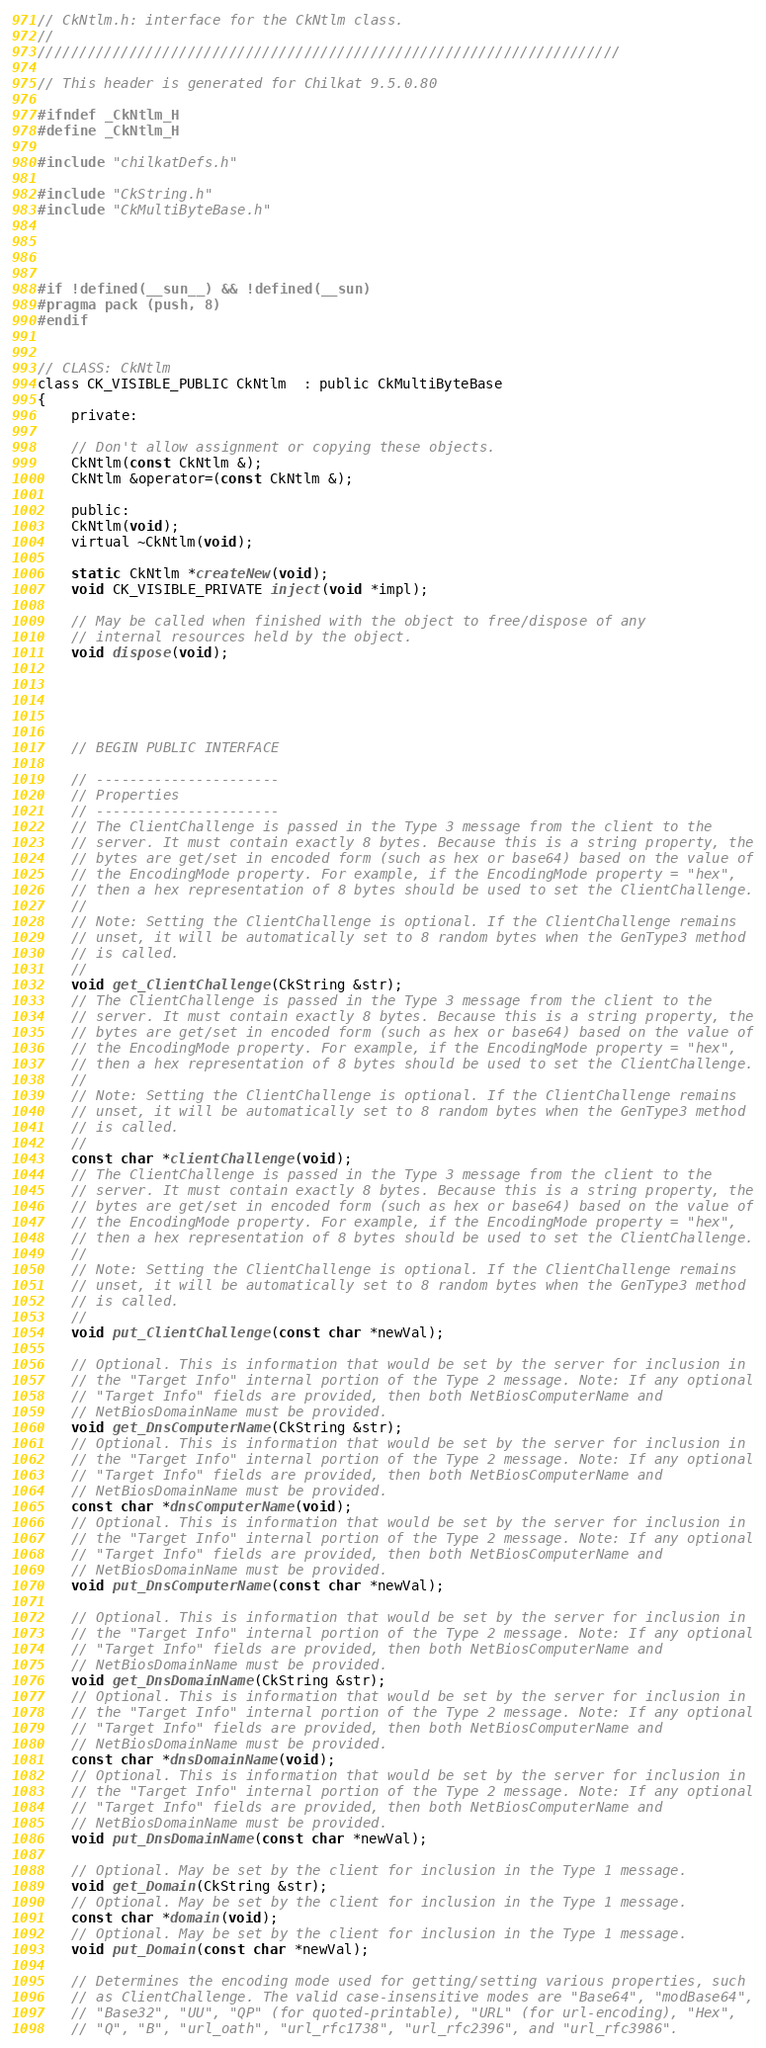Convert code to text. <code><loc_0><loc_0><loc_500><loc_500><_C_>// CkNtlm.h: interface for the CkNtlm class.
//
//////////////////////////////////////////////////////////////////////

// This header is generated for Chilkat 9.5.0.80

#ifndef _CkNtlm_H
#define _CkNtlm_H
	
#include "chilkatDefs.h"

#include "CkString.h"
#include "CkMultiByteBase.h"




#if !defined(__sun__) && !defined(__sun)
#pragma pack (push, 8)
#endif
 

// CLASS: CkNtlm
class CK_VISIBLE_PUBLIC CkNtlm  : public CkMultiByteBase
{
    private:

	// Don't allow assignment or copying these objects.
	CkNtlm(const CkNtlm &);
	CkNtlm &operator=(const CkNtlm &);

    public:
	CkNtlm(void);
	virtual ~CkNtlm(void);

	static CkNtlm *createNew(void);
	void CK_VISIBLE_PRIVATE inject(void *impl);

	// May be called when finished with the object to free/dispose of any
	// internal resources held by the object. 
	void dispose(void);

	
		
	

	// BEGIN PUBLIC INTERFACE

	// ----------------------
	// Properties
	// ----------------------
	// The ClientChallenge is passed in the Type 3 message from the client to the
	// server. It must contain exactly 8 bytes. Because this is a string property, the
	// bytes are get/set in encoded form (such as hex or base64) based on the value of
	// the EncodingMode property. For example, if the EncodingMode property = "hex",
	// then a hex representation of 8 bytes should be used to set the ClientChallenge.
	// 
	// Note: Setting the ClientChallenge is optional. If the ClientChallenge remains
	// unset, it will be automatically set to 8 random bytes when the GenType3 method
	// is called.
	// 
	void get_ClientChallenge(CkString &str);
	// The ClientChallenge is passed in the Type 3 message from the client to the
	// server. It must contain exactly 8 bytes. Because this is a string property, the
	// bytes are get/set in encoded form (such as hex or base64) based on the value of
	// the EncodingMode property. For example, if the EncodingMode property = "hex",
	// then a hex representation of 8 bytes should be used to set the ClientChallenge.
	// 
	// Note: Setting the ClientChallenge is optional. If the ClientChallenge remains
	// unset, it will be automatically set to 8 random bytes when the GenType3 method
	// is called.
	// 
	const char *clientChallenge(void);
	// The ClientChallenge is passed in the Type 3 message from the client to the
	// server. It must contain exactly 8 bytes. Because this is a string property, the
	// bytes are get/set in encoded form (such as hex or base64) based on the value of
	// the EncodingMode property. For example, if the EncodingMode property = "hex",
	// then a hex representation of 8 bytes should be used to set the ClientChallenge.
	// 
	// Note: Setting the ClientChallenge is optional. If the ClientChallenge remains
	// unset, it will be automatically set to 8 random bytes when the GenType3 method
	// is called.
	// 
	void put_ClientChallenge(const char *newVal);

	// Optional. This is information that would be set by the server for inclusion in
	// the "Target Info" internal portion of the Type 2 message. Note: If any optional
	// "Target Info" fields are provided, then both NetBiosComputerName and
	// NetBiosDomainName must be provided.
	void get_DnsComputerName(CkString &str);
	// Optional. This is information that would be set by the server for inclusion in
	// the "Target Info" internal portion of the Type 2 message. Note: If any optional
	// "Target Info" fields are provided, then both NetBiosComputerName and
	// NetBiosDomainName must be provided.
	const char *dnsComputerName(void);
	// Optional. This is information that would be set by the server for inclusion in
	// the "Target Info" internal portion of the Type 2 message. Note: If any optional
	// "Target Info" fields are provided, then both NetBiosComputerName and
	// NetBiosDomainName must be provided.
	void put_DnsComputerName(const char *newVal);

	// Optional. This is information that would be set by the server for inclusion in
	// the "Target Info" internal portion of the Type 2 message. Note: If any optional
	// "Target Info" fields are provided, then both NetBiosComputerName and
	// NetBiosDomainName must be provided.
	void get_DnsDomainName(CkString &str);
	// Optional. This is information that would be set by the server for inclusion in
	// the "Target Info" internal portion of the Type 2 message. Note: If any optional
	// "Target Info" fields are provided, then both NetBiosComputerName and
	// NetBiosDomainName must be provided.
	const char *dnsDomainName(void);
	// Optional. This is information that would be set by the server for inclusion in
	// the "Target Info" internal portion of the Type 2 message. Note: If any optional
	// "Target Info" fields are provided, then both NetBiosComputerName and
	// NetBiosDomainName must be provided.
	void put_DnsDomainName(const char *newVal);

	// Optional. May be set by the client for inclusion in the Type 1 message.
	void get_Domain(CkString &str);
	// Optional. May be set by the client for inclusion in the Type 1 message.
	const char *domain(void);
	// Optional. May be set by the client for inclusion in the Type 1 message.
	void put_Domain(const char *newVal);

	// Determines the encoding mode used for getting/setting various properties, such
	// as ClientChallenge. The valid case-insensitive modes are "Base64", "modBase64",
	// "Base32", "UU", "QP" (for quoted-printable), "URL" (for url-encoding), "Hex",
	// "Q", "B", "url_oath", "url_rfc1738", "url_rfc2396", and "url_rfc3986".</code> 